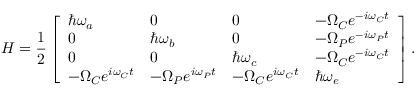Convert formula to latex. <formula><loc_0><loc_0><loc_500><loc_500>H = \frac { 1 } { 2 } \left [ \begin{array} { l l l l } { \hbar { \omega } _ { a } } & { 0 } & { 0 } & { - \Omega _ { C } e ^ { - i \omega _ { C } t } } \\ { 0 } & { \hbar { \omega } _ { b } } & { 0 } & { - \Omega _ { P } e ^ { - i \omega _ { P } t } } \\ { 0 } & { 0 } & { \hbar { \omega } _ { c } } & { - \Omega _ { C } e ^ { - i \omega _ { C } t } } \\ { - \Omega _ { C } e ^ { i \omega _ { C } t } } & { - \Omega _ { P } e ^ { i \omega _ { P } t } } & { - \Omega _ { C } e ^ { i \omega _ { C } t } } & { \hbar { \omega } _ { e } } \end{array} \right ] .</formula> 